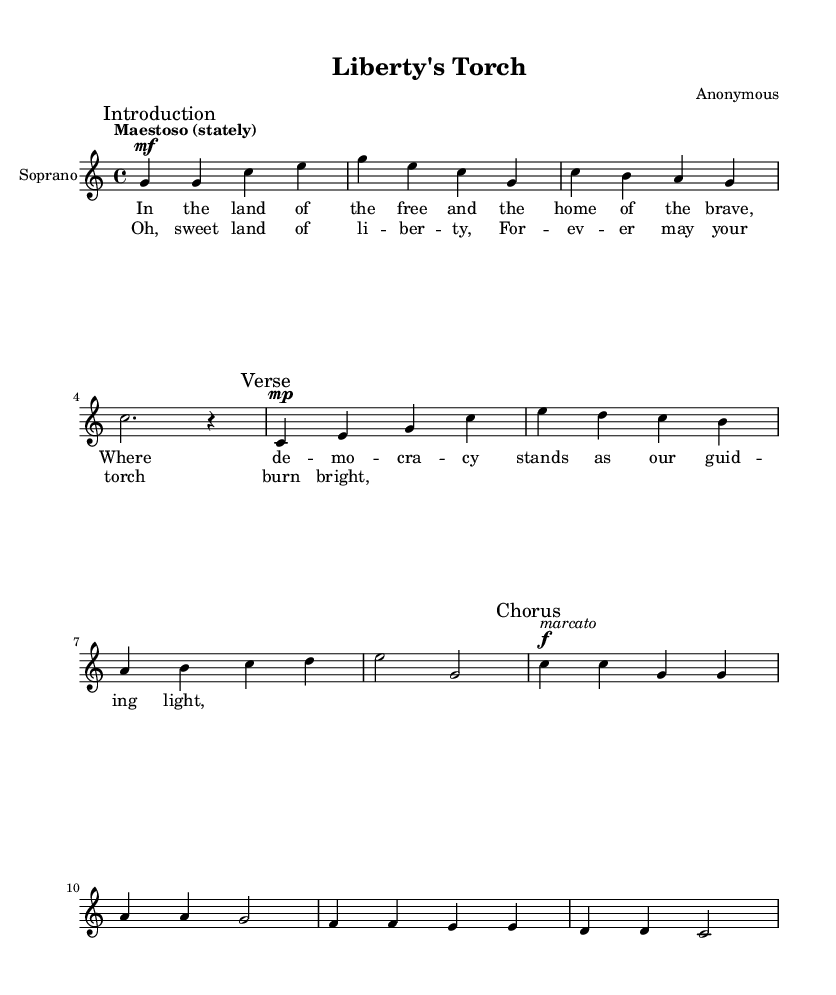What is the title of this piece? The title "Liberty's Torch" is located in the header section of the sheet music, clearly identifying the composition.
Answer: Liberty's Torch What is the key signature of this music? The key signature is C major, which is shown at the beginning of the piece through the indication of no sharps or flats.
Answer: C major What is the time signature of this opera? The time signature of 4/4 is indicated at the beginning of the music, specifying that there are four beats in each measure.
Answer: 4/4 What does the tempo marking indicate? The tempo marking states "Maestoso (stately)," suggesting that the piece should be played in a dignified and majestic manner, which can be found in the global section.
Answer: Maestoso What is the dynamic marking at the beginning of the chorus? The dynamic marking at the beginning of the chorus is forte, indicated by the symbol "f," which tells the performer to play loudly.
Answer: forte How many measures are in the verse section? The verse section consists of four measures, as counted from the notation provided before transitioning to the chorus.
Answer: four measures What is the theme of the lyrics in this opera? The theme revolves around freedom and the principles of democracy, as expressed in the lyrics discussing the land of the free and the concept of liberty.
Answer: Freedom and democracy 